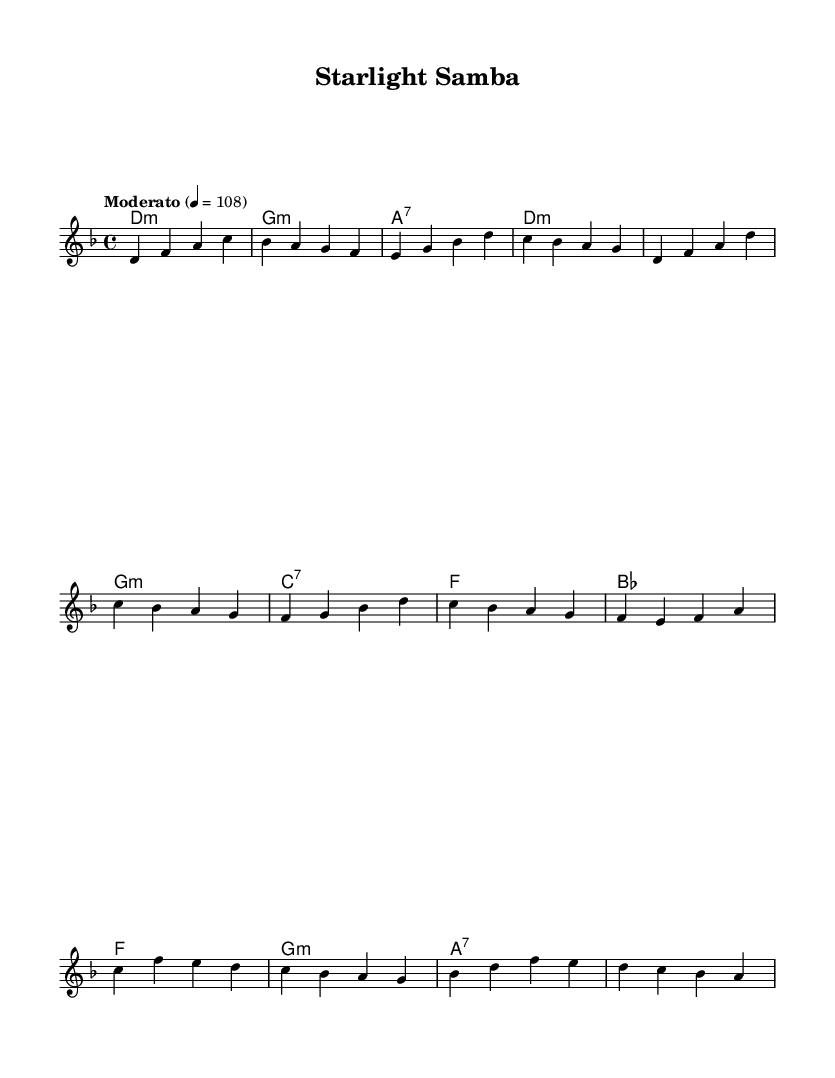What is the key signature of this music? The key signature indicated is D minor, as shown by the presence of one flat (B flat) in the staff.
Answer: D minor What is the time signature of the piece? The time signature is 4/4, which is typically noted near the beginning of the score. This means there are four beats per measure.
Answer: 4/4 What is the tempo marking for this piece? The tempo marking is "Moderato," which suggests a moderate speed, typically around 108 beats per minute, displayed next to the tempo indication.
Answer: Moderato How many measures are in the chorus section? By counting the measures of the chorus section as notated, there are four measures in total. Each group of notes between the bar lines indicates one measure.
Answer: Four Which chord follows the first measure of the verse? The chord notated in the harmony part that follows the first measure of the verse is D minor, which is labeled clearly in the score.
Answer: D minor What type of music genre does this piece represent? This composition is a fusion of Latin-infused adult contemporary, reflected in its rhythmic patterns and harmonic structure, blending modern and vintage influences.
Answer: Fusion What is the first note of the melody? The first note of the melody as indicated on the staff is D, which is the first note played in the introduction.
Answer: D 